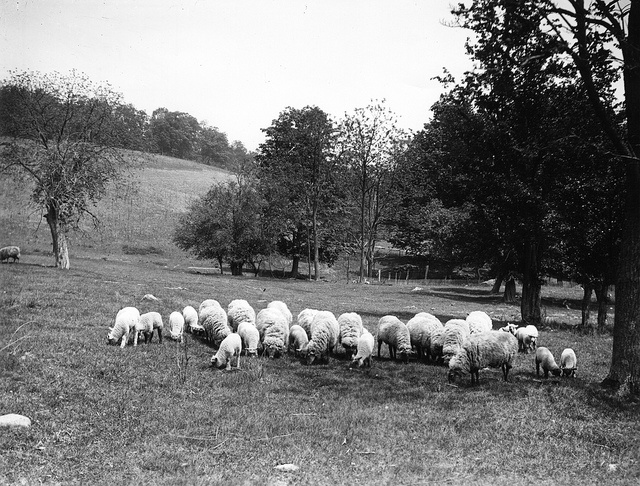Describe the objects in this image and their specific colors. I can see sheep in lightgray, gray, black, and darkgray tones, sheep in lightgray, darkgray, gray, and black tones, sheep in lightgray, darkgray, gray, and black tones, sheep in lightgray, black, darkgray, and gray tones, and sheep in lightgray, black, darkgray, and gray tones in this image. 